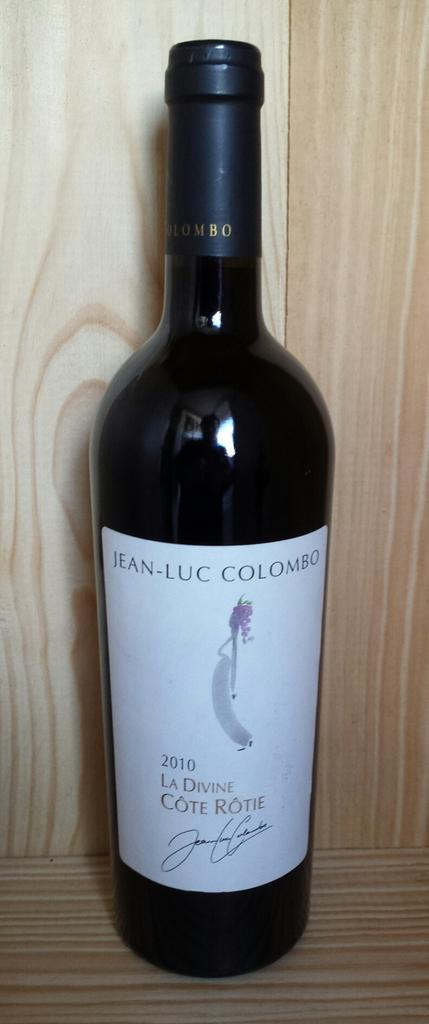<image>
Provide a brief description of the given image. A black bottle of Jean Luc Colombo branded wine. 